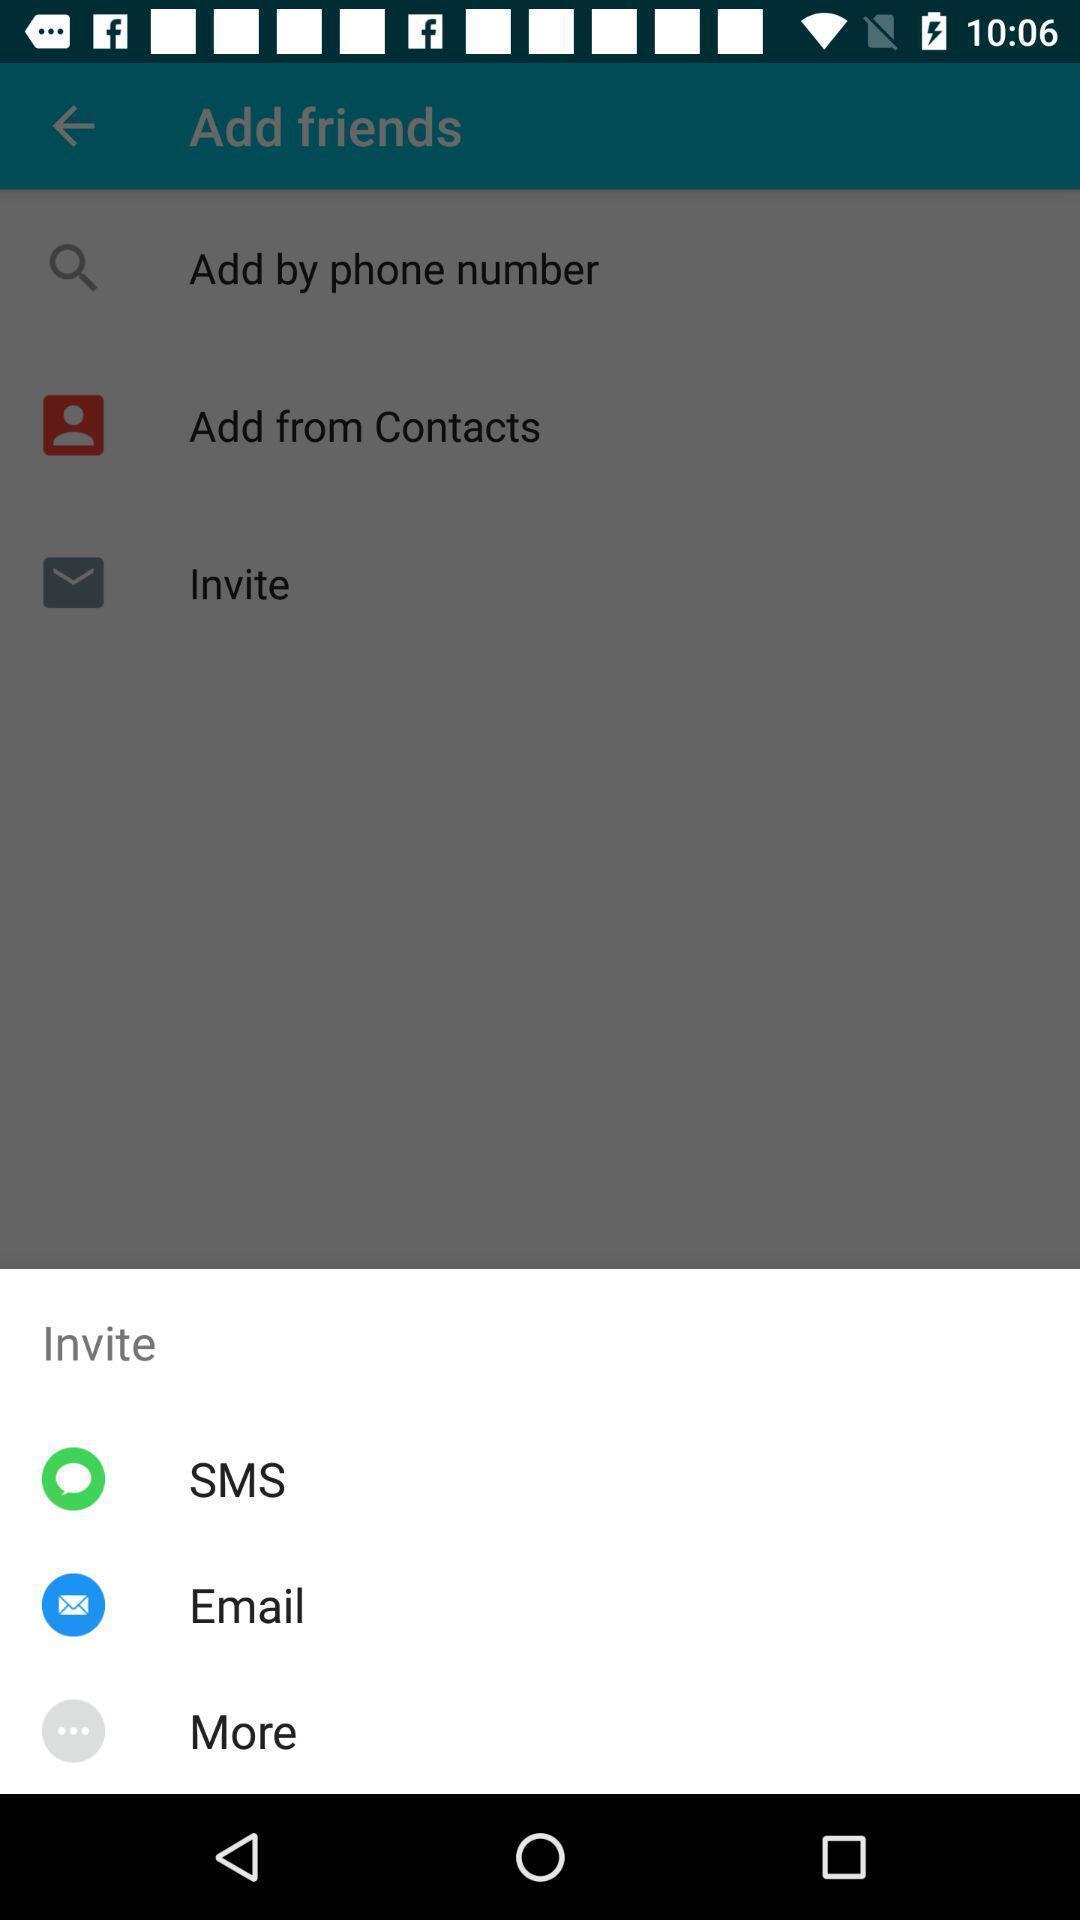What details can you identify in this image? Pop-up shows invite with multiple applications. 